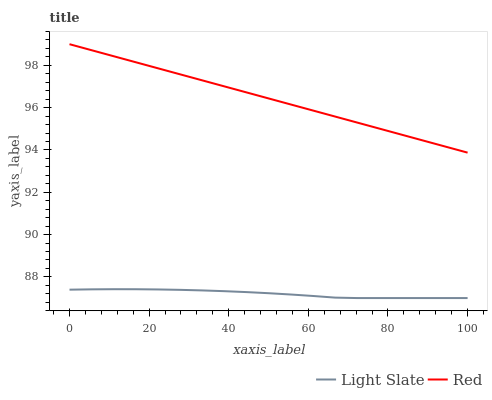Does Red have the minimum area under the curve?
Answer yes or no. No. Is Red the roughest?
Answer yes or no. No. Does Red have the lowest value?
Answer yes or no. No. Is Light Slate less than Red?
Answer yes or no. Yes. Is Red greater than Light Slate?
Answer yes or no. Yes. Does Light Slate intersect Red?
Answer yes or no. No. 